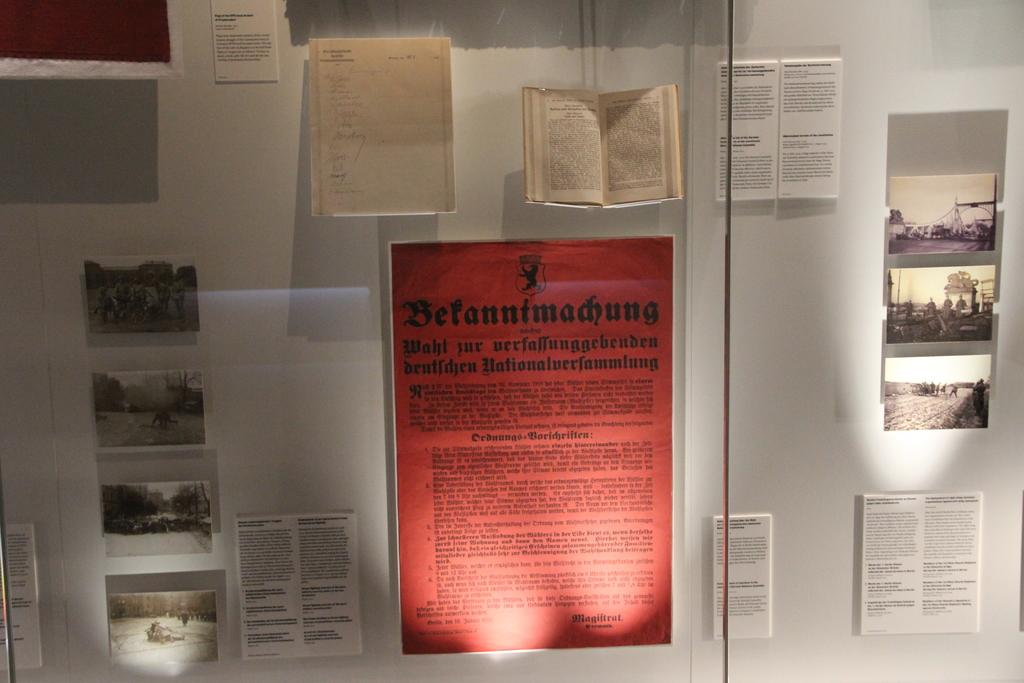Provide a one-sentence caption for the provided image. Red paper on a wall titled "Betanntmadhung" for display. 